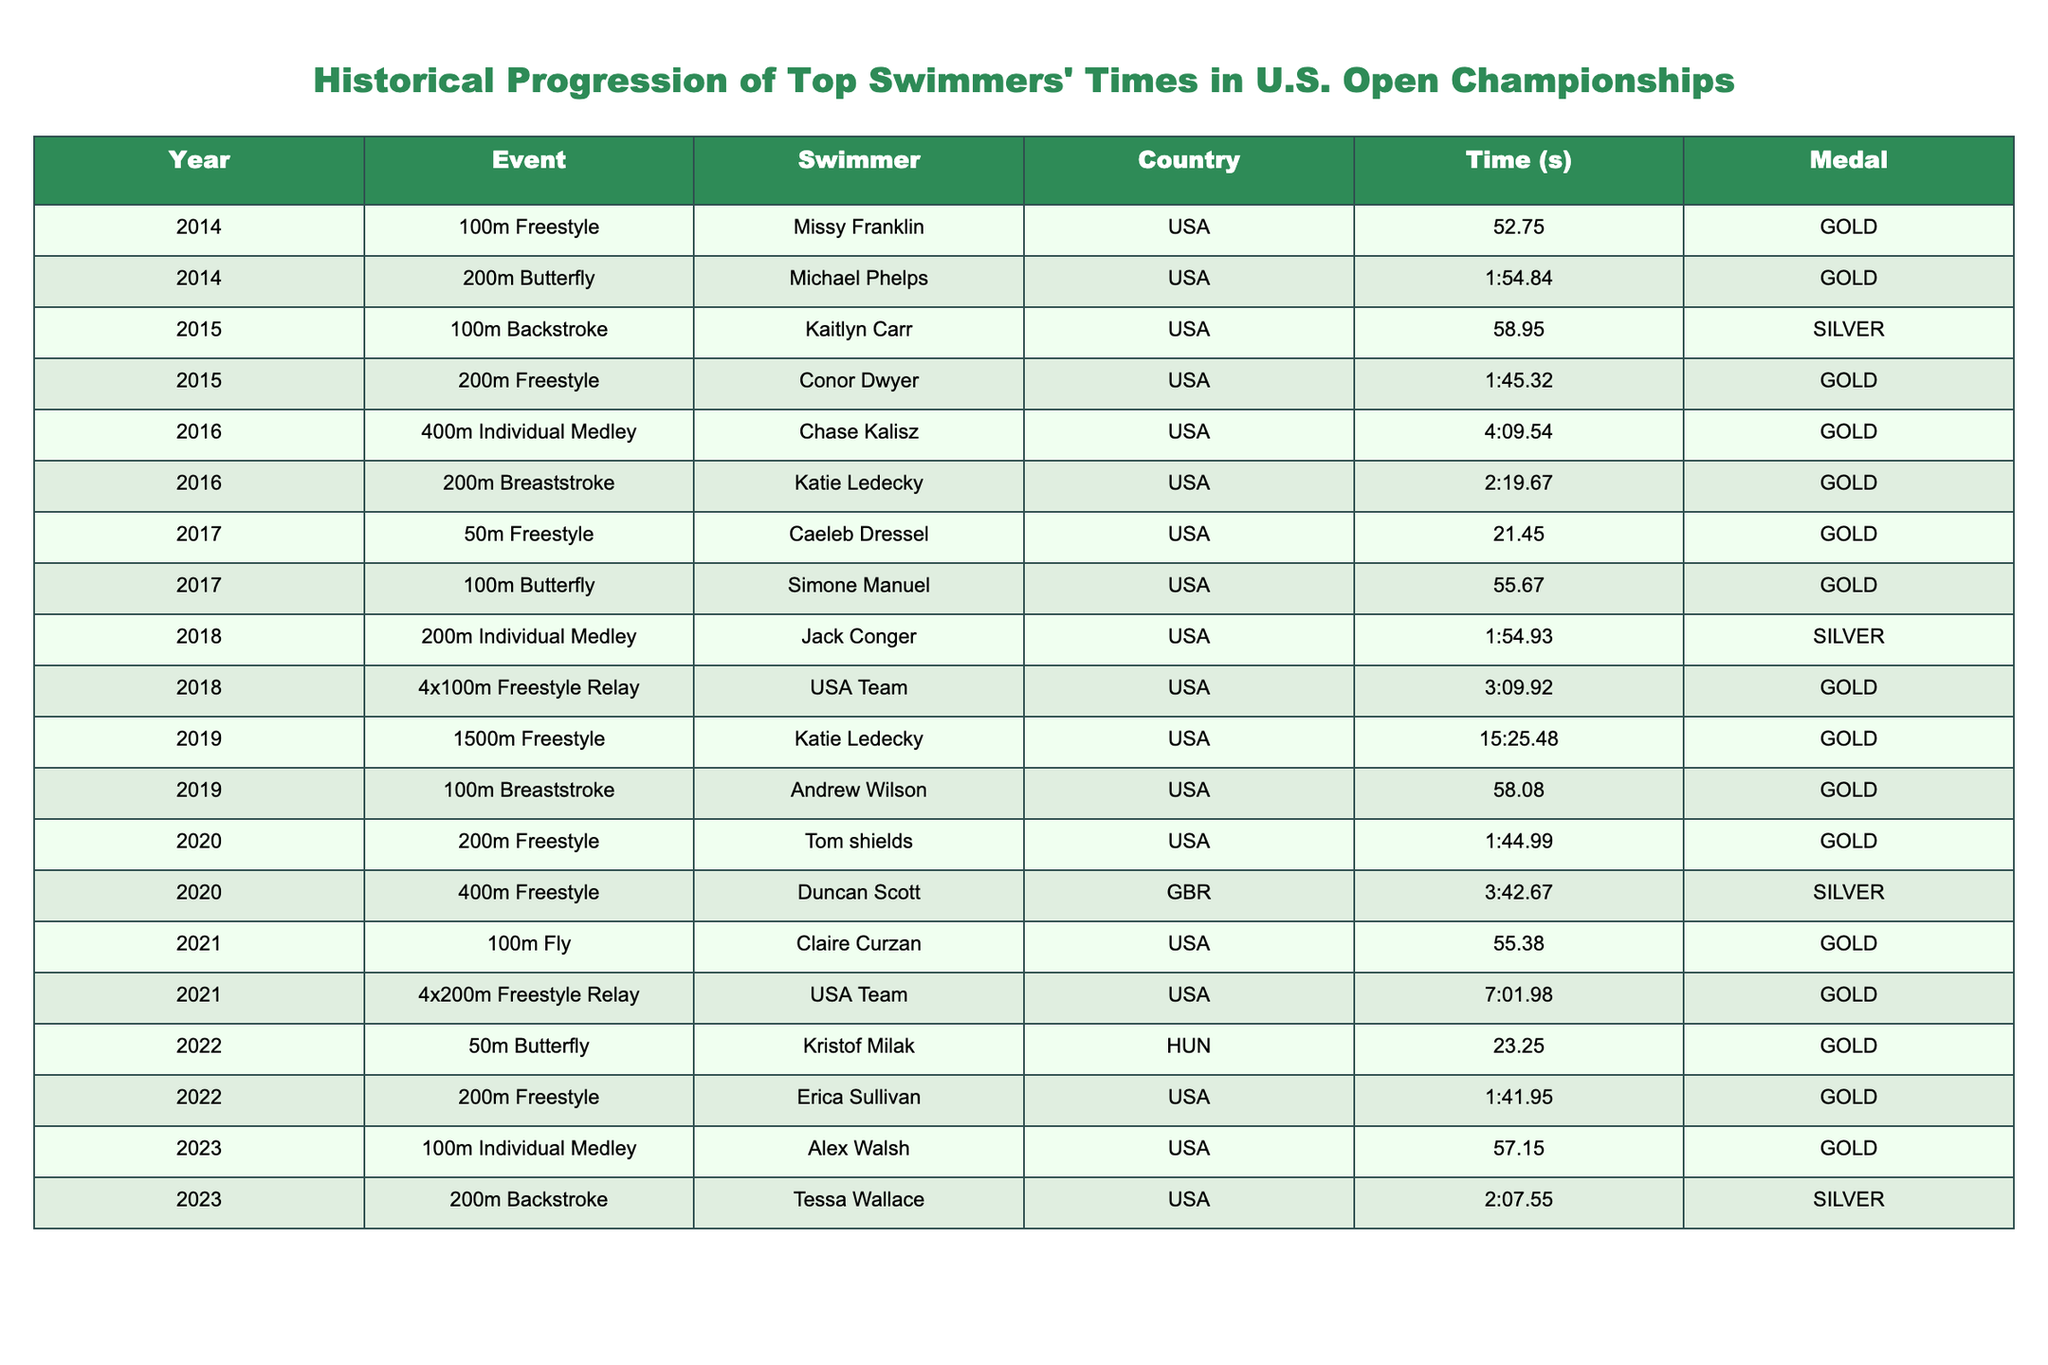What swimmer won the GOLD medal in the 200m Butterfly in 2014? Referring to the table, Missy Franklin won the GOLD medal in the 100m Freestyle, and Michael Phelps won the GOLD medal in the 200m Butterfly in 2014.
Answer: Michael Phelps Which event had the fastest time recorded in the table? Reviewing the times listed, the lowest time recorded is from the 50m Freestyle by Caeleb Dressel in 2017 with a time of 21.45 seconds.
Answer: 21.45 seconds How many GOLD medals did USA swimmers win in total from 2014 to 2023? By counting the entries marked as GOLD medals for USA swimmers in the table, there are 10 events where USA swimmers won GOLD.
Answer: 10 Was there ever a year in which swimmers from the USA won GOLD in both the 100m and 200m events? The data shows that in 2015 and 2022, USA swimmers won GOLD in both the 100m and the 200m events (100m Backstroke and 200m Freestyle, then 50m Butterfly and 200m Freestyle). Therefore, the answer is true.
Answer: True What was the time difference between the fastest and the slowest recorded times in the table? The fastest time is from the 50m Freestyle at 21.45 seconds, and the slowest is from the 1500m Freestyle at 15:25.48 (or 925 seconds). The difference is 925 - 21.45 = 903.55 seconds.
Answer: 903.55 seconds In which event did Katie Ledecky win her GOLD medal? The table indicates that Katie Ledecky won the GOLD medal in the 200m Breaststroke in 2016 and the 1500m Freestyle in 2019.
Answer: 200m Breaststroke, 1500m Freestyle What is the average time for the 200m Freestyle events recorded in the table? For the 200m Freestyle entries in the table, we have Erica Sullivan's time of 1:41.95 in 2022 and Conor Dwyer's time of 1:45.32 in 2015. The average can be calculated: (101.95 + 105.32) / 2 = 203.27 / 2 = 101.635 seconds or 1:41.635.
Answer: 1:41.635 Which swimmer has recorded times in the events listed more than once during the decade? By examining the swimmers in the table, Katie Ledecky appears in two events, winning in 200m Breaststroke and 1500m Freestyle.
Answer: Katie Ledecky 